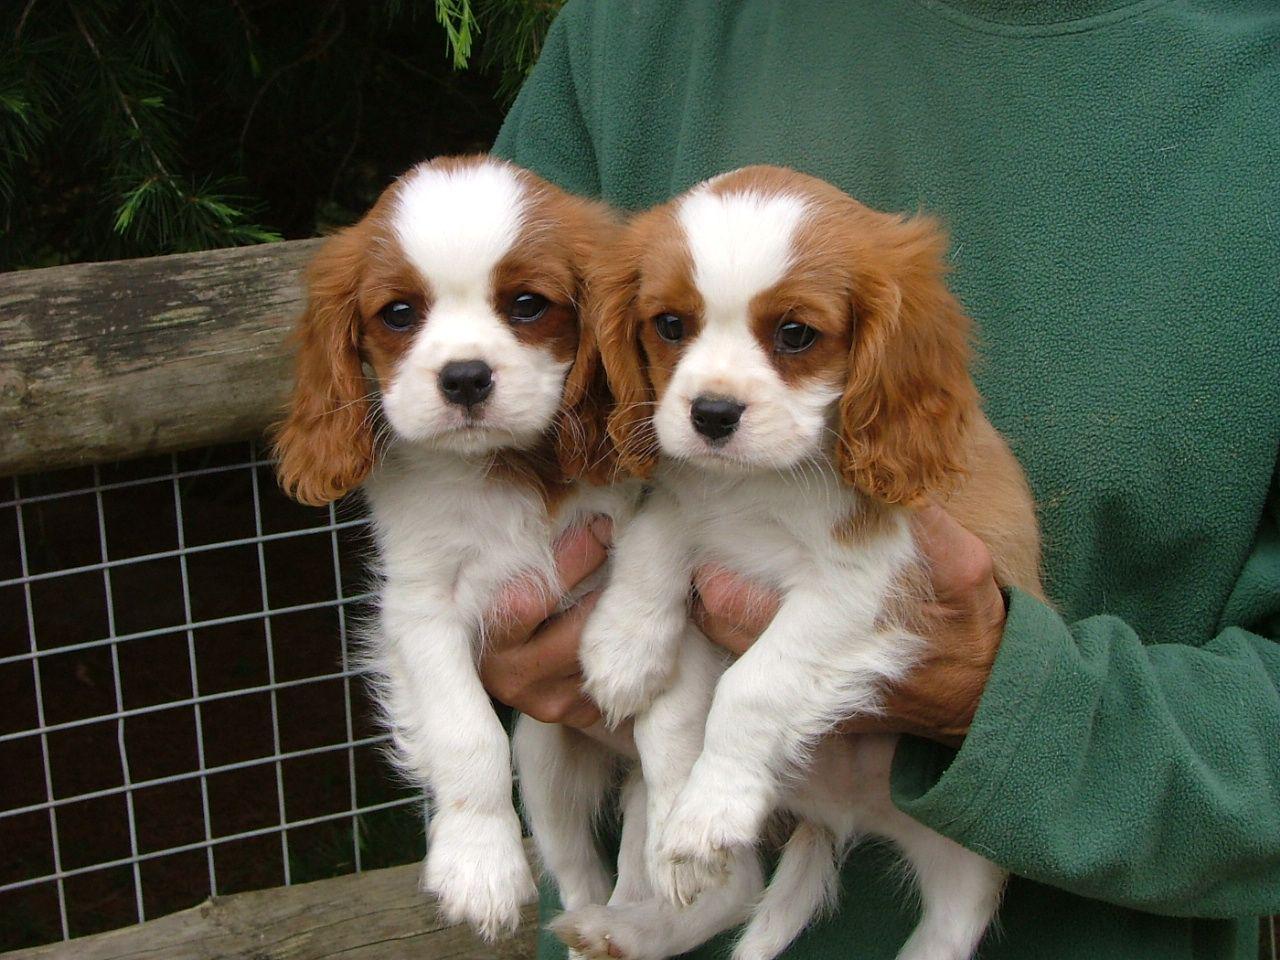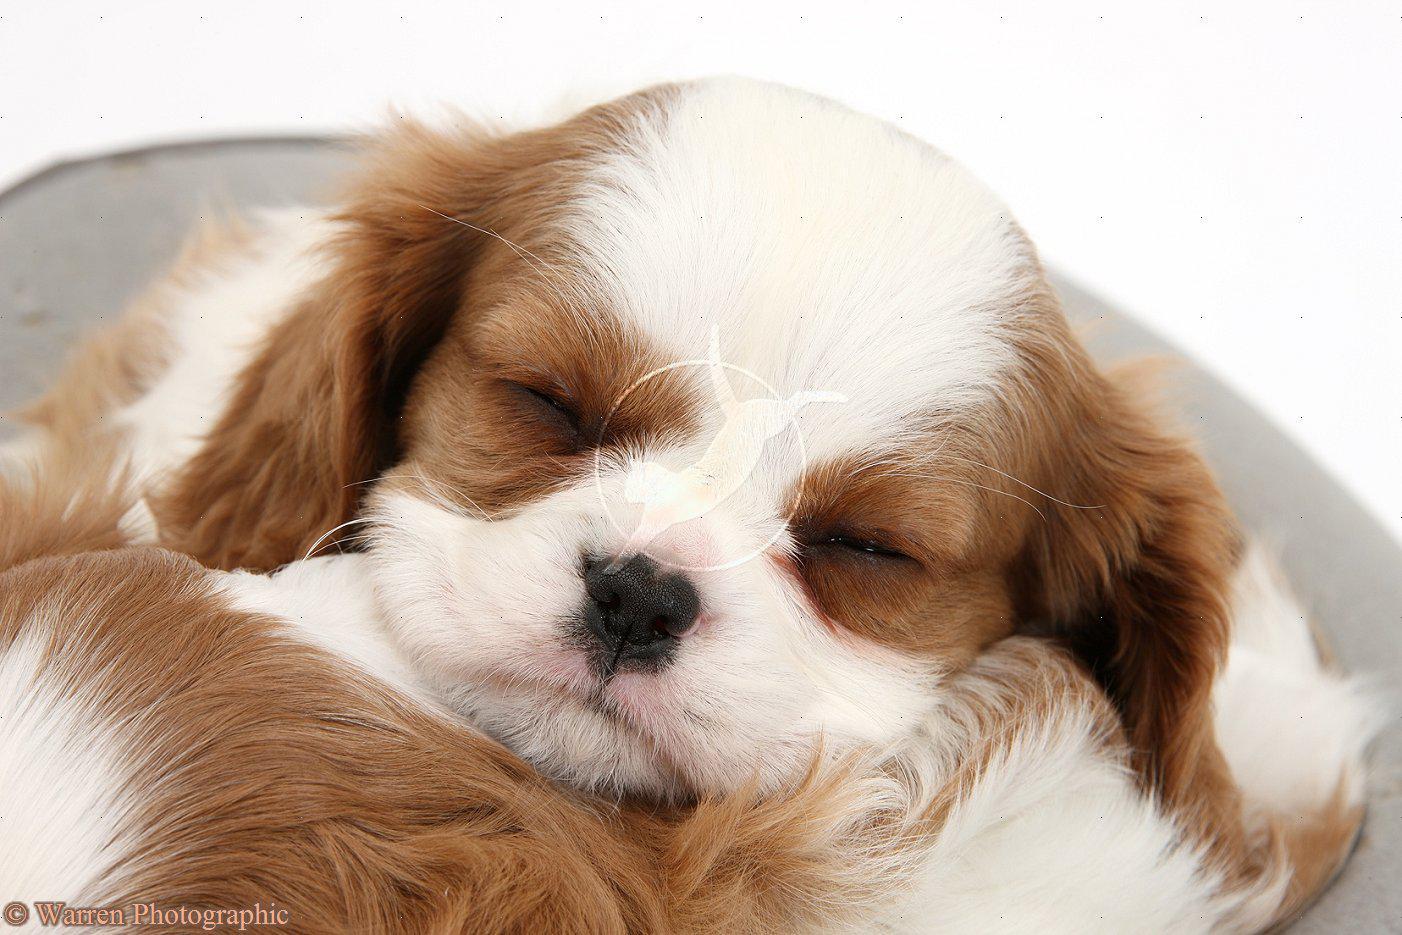The first image is the image on the left, the second image is the image on the right. For the images displayed, is the sentence "There are exactly two animals in the image on the left." factually correct? Answer yes or no. Yes. 